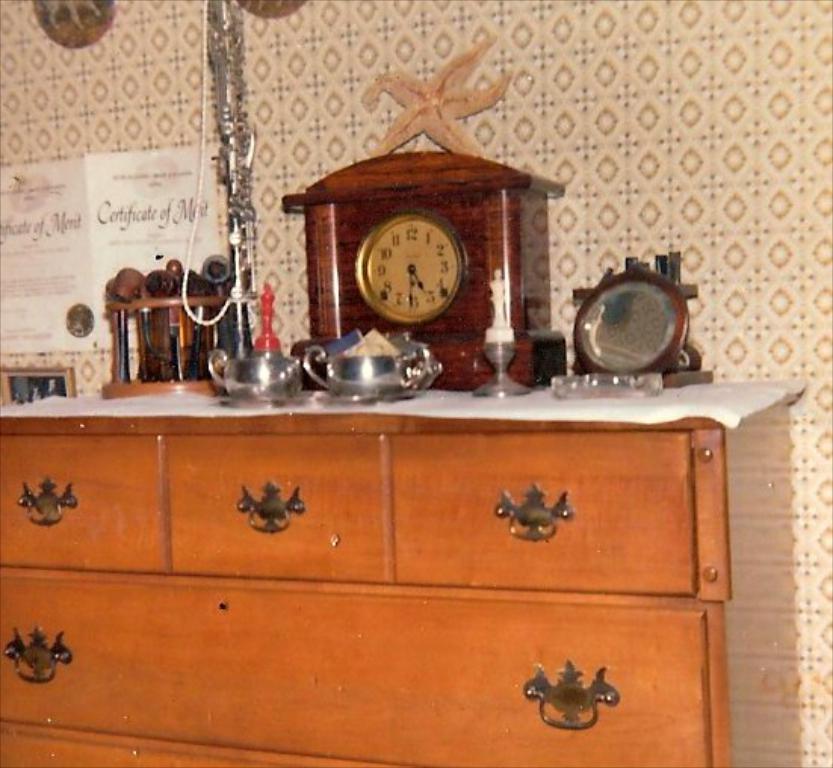Describe this image in one or two sentences. In this picture we can see chest of drawers in the front, there is a clock, two bowls, smoking pipes, a mirror present on this chest, in the background there is a wall, there is a paper pasted on the wall, we can see some text on this paper. 